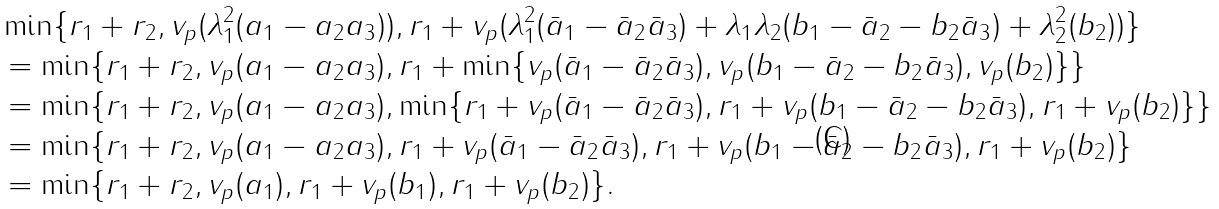<formula> <loc_0><loc_0><loc_500><loc_500>& \min \{ r _ { 1 } + r _ { 2 } , v _ { p } ( \lambda _ { 1 } ^ { 2 } ( a _ { 1 } - a _ { 2 } a _ { 3 } ) ) , r _ { 1 } + v _ { p } ( \lambda _ { 1 } ^ { 2 } ( \bar { a } _ { 1 } - \bar { a } _ { 2 } \bar { a } _ { 3 } ) + \lambda _ { 1 } \lambda _ { 2 } ( b _ { 1 } - \bar { a } _ { 2 } - b _ { 2 } \bar { a } _ { 3 } ) + \lambda _ { 2 } ^ { 2 } ( b _ { 2 } ) ) \} \\ & = \min \{ r _ { 1 } + r _ { 2 } , v _ { p } ( a _ { 1 } - a _ { 2 } a _ { 3 } ) , r _ { 1 } + \min \{ v _ { p } ( \bar { a } _ { 1 } - \bar { a } _ { 2 } \bar { a } _ { 3 } ) , v _ { p } ( b _ { 1 } - \bar { a } _ { 2 } - b _ { 2 } \bar { a } _ { 3 } ) , v _ { p } ( b _ { 2 } ) \} \} \\ & = \min \{ r _ { 1 } + r _ { 2 } , v _ { p } ( a _ { 1 } - a _ { 2 } a _ { 3 } ) , \min \{ r _ { 1 } + v _ { p } ( \bar { a } _ { 1 } - \bar { a } _ { 2 } \bar { a } _ { 3 } ) , r _ { 1 } + v _ { p } ( b _ { 1 } - \bar { a } _ { 2 } - b _ { 2 } \bar { a } _ { 3 } ) , r _ { 1 } + v _ { p } ( b _ { 2 } ) \} \} \\ & = \min \{ r _ { 1 } + r _ { 2 } , v _ { p } ( a _ { 1 } - a _ { 2 } a _ { 3 } ) , r _ { 1 } + v _ { p } ( \bar { a } _ { 1 } - \bar { a } _ { 2 } \bar { a } _ { 3 } ) , r _ { 1 } + v _ { p } ( b _ { 1 } - \bar { a } _ { 2 } - b _ { 2 } \bar { a } _ { 3 } ) , r _ { 1 } + v _ { p } ( b _ { 2 } ) \} \\ & = \min \{ r _ { 1 } + r _ { 2 } , v _ { p } ( a _ { 1 } ) , r _ { 1 } + v _ { p } ( b _ { 1 } ) , r _ { 1 } + v _ { p } ( b _ { 2 } ) \} .</formula> 